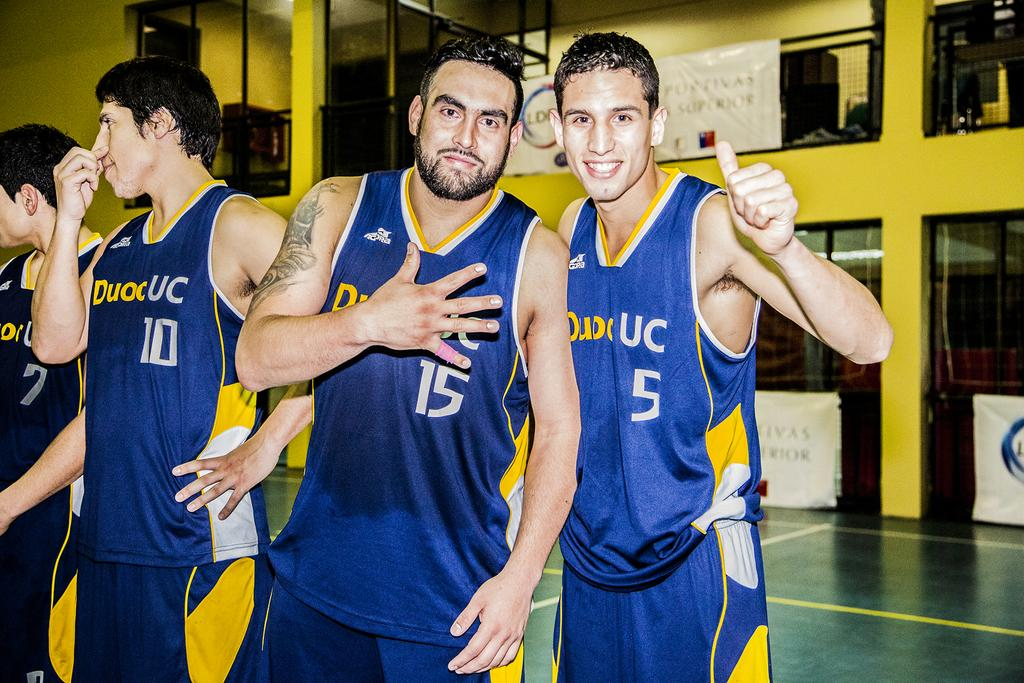<image>
Render a clear and concise summary of the photo. Several players wear their DuocUC jerseys and post for a photo. 